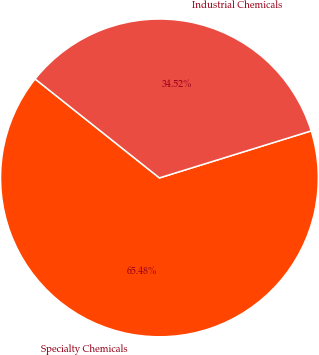<chart> <loc_0><loc_0><loc_500><loc_500><pie_chart><fcel>Specialty Chemicals<fcel>Industrial Chemicals<nl><fcel>65.48%<fcel>34.52%<nl></chart> 